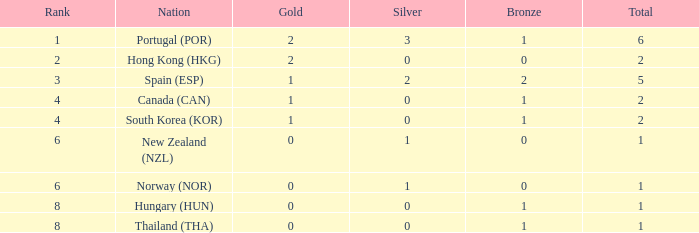What is the lowest Total containing a Bronze of 0 and Rank smaller than 2? None. 